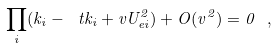<formula> <loc_0><loc_0><loc_500><loc_500>\prod _ { i } ( k _ { i } - \ t k _ { i } + v U ^ { 2 } _ { e i } ) + O ( v ^ { 2 } ) = 0 \ ,</formula> 